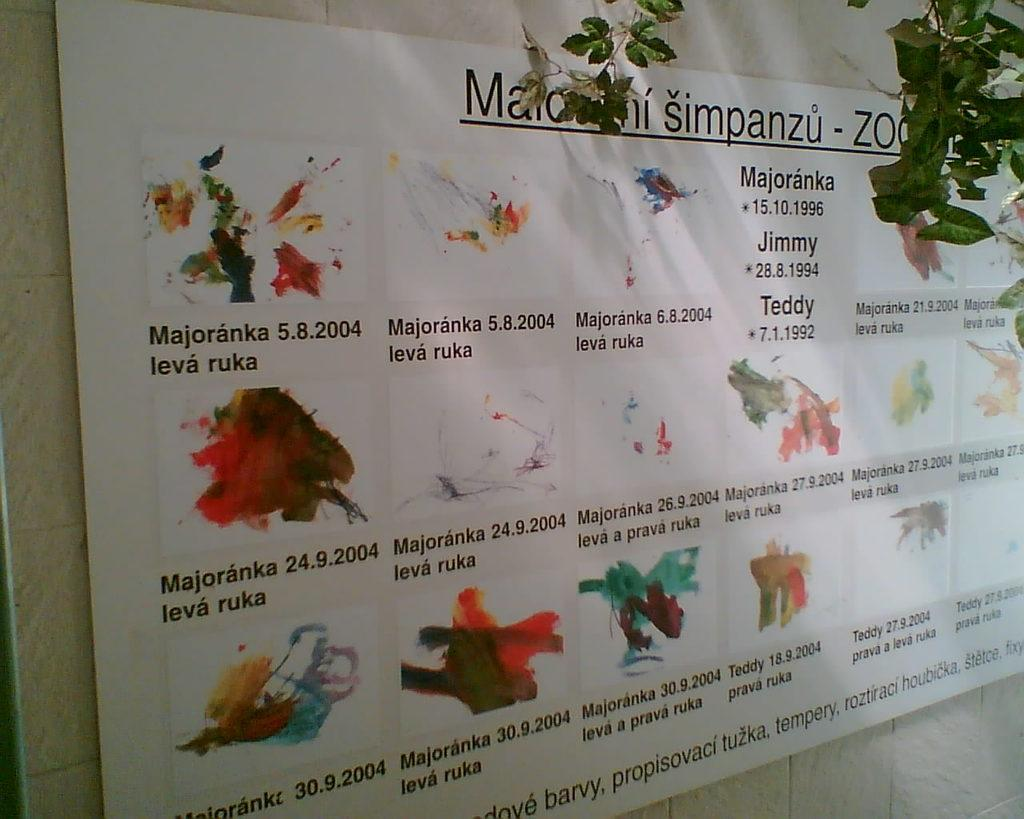What is hanging on the wall in the image? There is a banner on the wall in the image. What can be seen in the top right corner of the image? There are branches visible in the top right corner of the image. What type of underwear is hanging from the branches in the image? There are no underwear or any clothing items present in the image; only a banner and branches can be seen. 